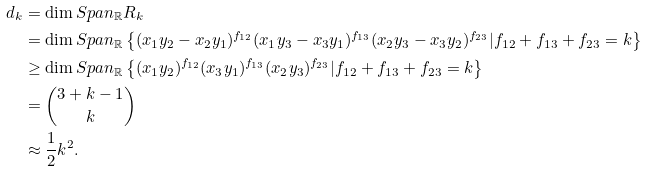Convert formula to latex. <formula><loc_0><loc_0><loc_500><loc_500>d _ { k } & = \dim S p a n _ { \mathbb { R } } R _ { k } \\ & = \dim S p a n _ { \mathbb { R } } \left \{ ( { x _ { 1 } y _ { 2 } } - x _ { 2 } y _ { 1 } ) ^ { f _ { 1 2 } } ( x _ { 1 } y _ { 3 } - x _ { 3 } y _ { 1 } ) ^ { f _ { 1 3 } } ( x _ { 2 } y _ { 3 } - x _ { 3 } y _ { 2 } ) ^ { f _ { 2 3 } } | f _ { 1 2 } + f _ { 1 3 } + f _ { 2 3 } = k \right \} \\ & \geq \dim S p a n _ { \mathbb { R } } \left \{ ( { x _ { 1 } y _ { 2 } } ) ^ { f _ { 1 2 } } ( x _ { 3 } y _ { 1 } ) ^ { f _ { 1 3 } } ( x _ { 2 } y _ { 3 } ) ^ { f _ { 2 3 } } | f _ { 1 2 } + f _ { 1 3 } + f _ { 2 3 } = k \right \} \\ & = { 3 + k - 1 \choose k } \\ & \approx \frac { 1 } { 2 } k ^ { 2 } .</formula> 